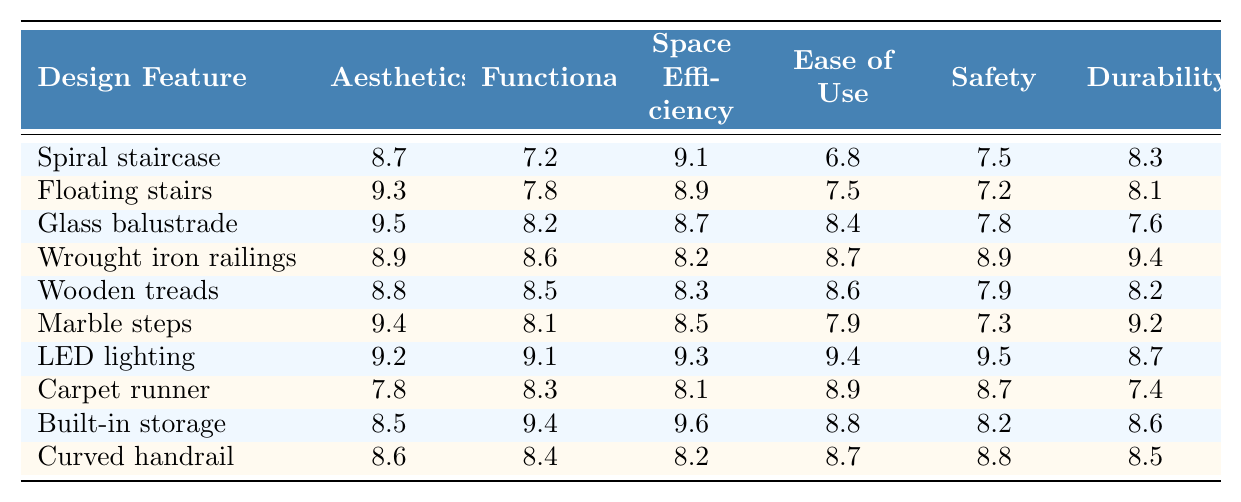What is the satisfaction score for aesthetics of the Floating stairs? The table indicates that the aesthetics score for Floating stairs is 9.3.
Answer: 9.3 Which staircase feature has the highest durability score? By comparing the durability scores in the table, Wrought iron railings have the highest score at 9.4.
Answer: Wrought iron railings What is the average safety score across all the staircase features? The safety scores are 7.5, 7.2, 7.8, 8.9, 7.9, 7.3, 9.5, 8.7, 8.2, and 8.8. Adding these gives 78.8, and dividing by 10 yields an average of 7.88.
Answer: 7.88 Is the satisfaction score for ease of use for Built-in storage greater than that for Spiral staircase? The ease of use for Built-in storage is 8.8, while for Spiral staircase it is 6.8. Since 8.8 is greater than 6.8, the statement is true.
Answer: Yes Which design feature has the lowest score in functionality? Upon examining the functionality scores, Spiral staircase has the lowest score at 7.2, compared to others.
Answer: Spiral staircase What is the difference in aesthetics scores between Glass balustrade and Wooden treads? Glass balustrade has an aesthetics score of 9.5 and Wooden treads has a score of 8.8. The difference is 9.5 - 8.8 = 0.7.
Answer: 0.7 Does LED lighting score higher in safety than Carpet runner? LED lighting has a safety score of 9.5 while Carpet runner has a score of 8.7. Therefore, LED lighting scores higher in safety.
Answer: Yes What is the composite score for the Floating stairs from the characteristics of functionality, ease of use, and safety? The scores for Floating stairs are 7.8 (functionality) + 7.5 (ease of use) + 7.2 (safety) = 22.5.
Answer: 22.5 Which feature has the second highest score in space efficiency? The space efficiency scores show that Built-in storage has the highest at 9.6, while Floating stairs is second with 8.9.
Answer: Floating stairs What is the highest score in aesthetics and what feature does it represent? The aesthetics score of 9.5 is the highest, representing the Glass balustrade.
Answer: Glass balustrade 